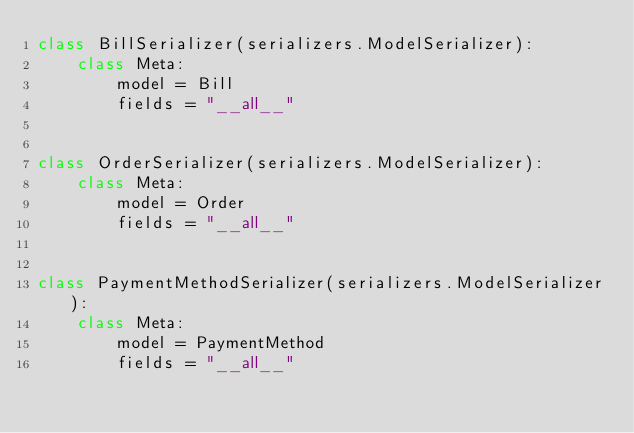<code> <loc_0><loc_0><loc_500><loc_500><_Python_>class BillSerializer(serializers.ModelSerializer):
    class Meta:
        model = Bill
        fields = "__all__"


class OrderSerializer(serializers.ModelSerializer):
    class Meta:
        model = Order
        fields = "__all__"


class PaymentMethodSerializer(serializers.ModelSerializer):
    class Meta:
        model = PaymentMethod
        fields = "__all__"
</code> 